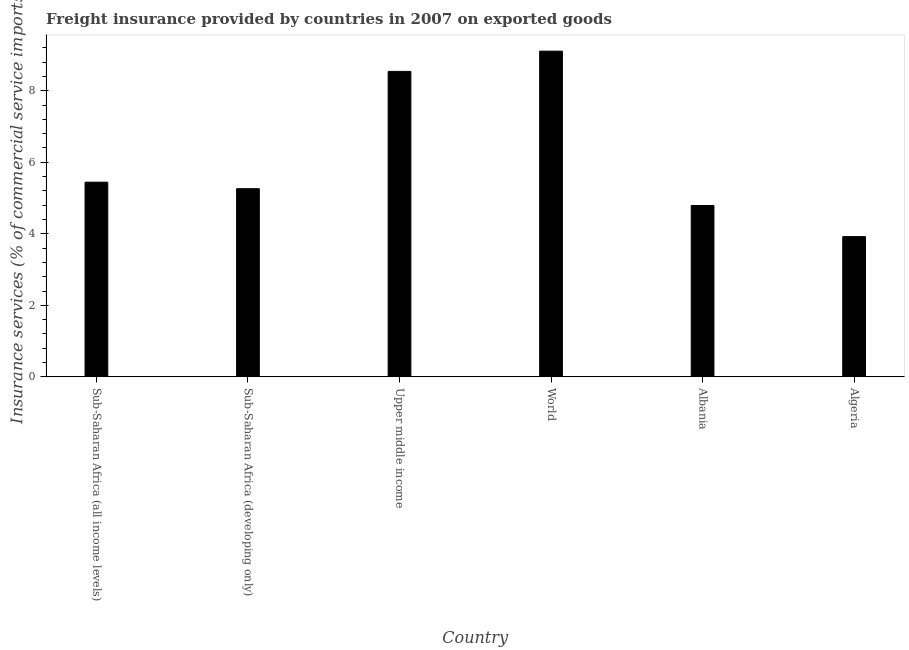Does the graph contain grids?
Your answer should be compact. No. What is the title of the graph?
Offer a very short reply. Freight insurance provided by countries in 2007 on exported goods . What is the label or title of the X-axis?
Provide a succinct answer. Country. What is the label or title of the Y-axis?
Provide a short and direct response. Insurance services (% of commercial service imports). What is the freight insurance in Algeria?
Keep it short and to the point. 3.92. Across all countries, what is the maximum freight insurance?
Ensure brevity in your answer.  9.11. Across all countries, what is the minimum freight insurance?
Offer a very short reply. 3.92. In which country was the freight insurance maximum?
Your response must be concise. World. In which country was the freight insurance minimum?
Make the answer very short. Algeria. What is the sum of the freight insurance?
Provide a succinct answer. 37.06. What is the difference between the freight insurance in Sub-Saharan Africa (all income levels) and Upper middle income?
Ensure brevity in your answer.  -3.1. What is the average freight insurance per country?
Ensure brevity in your answer.  6.18. What is the median freight insurance?
Your response must be concise. 5.35. In how many countries, is the freight insurance greater than 5.2 %?
Offer a very short reply. 4. What is the ratio of the freight insurance in Albania to that in Sub-Saharan Africa (developing only)?
Provide a short and direct response. 0.91. What is the difference between the highest and the second highest freight insurance?
Your answer should be very brief. 0.57. What is the difference between the highest and the lowest freight insurance?
Make the answer very short. 5.18. In how many countries, is the freight insurance greater than the average freight insurance taken over all countries?
Offer a terse response. 2. How many bars are there?
Offer a terse response. 6. Are all the bars in the graph horizontal?
Give a very brief answer. No. How many countries are there in the graph?
Offer a very short reply. 6. What is the difference between two consecutive major ticks on the Y-axis?
Your answer should be compact. 2. Are the values on the major ticks of Y-axis written in scientific E-notation?
Your answer should be very brief. No. What is the Insurance services (% of commercial service imports) in Sub-Saharan Africa (all income levels)?
Make the answer very short. 5.44. What is the Insurance services (% of commercial service imports) in Sub-Saharan Africa (developing only)?
Make the answer very short. 5.26. What is the Insurance services (% of commercial service imports) of Upper middle income?
Offer a terse response. 8.54. What is the Insurance services (% of commercial service imports) of World?
Provide a short and direct response. 9.11. What is the Insurance services (% of commercial service imports) of Albania?
Offer a terse response. 4.79. What is the Insurance services (% of commercial service imports) of Algeria?
Offer a terse response. 3.92. What is the difference between the Insurance services (% of commercial service imports) in Sub-Saharan Africa (all income levels) and Sub-Saharan Africa (developing only)?
Make the answer very short. 0.18. What is the difference between the Insurance services (% of commercial service imports) in Sub-Saharan Africa (all income levels) and Upper middle income?
Your answer should be very brief. -3.1. What is the difference between the Insurance services (% of commercial service imports) in Sub-Saharan Africa (all income levels) and World?
Provide a short and direct response. -3.66. What is the difference between the Insurance services (% of commercial service imports) in Sub-Saharan Africa (all income levels) and Albania?
Provide a succinct answer. 0.65. What is the difference between the Insurance services (% of commercial service imports) in Sub-Saharan Africa (all income levels) and Algeria?
Give a very brief answer. 1.52. What is the difference between the Insurance services (% of commercial service imports) in Sub-Saharan Africa (developing only) and Upper middle income?
Offer a very short reply. -3.28. What is the difference between the Insurance services (% of commercial service imports) in Sub-Saharan Africa (developing only) and World?
Ensure brevity in your answer.  -3.85. What is the difference between the Insurance services (% of commercial service imports) in Sub-Saharan Africa (developing only) and Albania?
Give a very brief answer. 0.47. What is the difference between the Insurance services (% of commercial service imports) in Sub-Saharan Africa (developing only) and Algeria?
Make the answer very short. 1.34. What is the difference between the Insurance services (% of commercial service imports) in Upper middle income and World?
Your answer should be very brief. -0.57. What is the difference between the Insurance services (% of commercial service imports) in Upper middle income and Albania?
Provide a short and direct response. 3.75. What is the difference between the Insurance services (% of commercial service imports) in Upper middle income and Algeria?
Offer a very short reply. 4.62. What is the difference between the Insurance services (% of commercial service imports) in World and Albania?
Your response must be concise. 4.31. What is the difference between the Insurance services (% of commercial service imports) in World and Algeria?
Make the answer very short. 5.18. What is the difference between the Insurance services (% of commercial service imports) in Albania and Algeria?
Offer a very short reply. 0.87. What is the ratio of the Insurance services (% of commercial service imports) in Sub-Saharan Africa (all income levels) to that in Sub-Saharan Africa (developing only)?
Keep it short and to the point. 1.03. What is the ratio of the Insurance services (% of commercial service imports) in Sub-Saharan Africa (all income levels) to that in Upper middle income?
Provide a succinct answer. 0.64. What is the ratio of the Insurance services (% of commercial service imports) in Sub-Saharan Africa (all income levels) to that in World?
Provide a short and direct response. 0.6. What is the ratio of the Insurance services (% of commercial service imports) in Sub-Saharan Africa (all income levels) to that in Albania?
Your answer should be very brief. 1.14. What is the ratio of the Insurance services (% of commercial service imports) in Sub-Saharan Africa (all income levels) to that in Algeria?
Ensure brevity in your answer.  1.39. What is the ratio of the Insurance services (% of commercial service imports) in Sub-Saharan Africa (developing only) to that in Upper middle income?
Your response must be concise. 0.62. What is the ratio of the Insurance services (% of commercial service imports) in Sub-Saharan Africa (developing only) to that in World?
Offer a terse response. 0.58. What is the ratio of the Insurance services (% of commercial service imports) in Sub-Saharan Africa (developing only) to that in Albania?
Provide a succinct answer. 1.1. What is the ratio of the Insurance services (% of commercial service imports) in Sub-Saharan Africa (developing only) to that in Algeria?
Make the answer very short. 1.34. What is the ratio of the Insurance services (% of commercial service imports) in Upper middle income to that in World?
Give a very brief answer. 0.94. What is the ratio of the Insurance services (% of commercial service imports) in Upper middle income to that in Albania?
Your response must be concise. 1.78. What is the ratio of the Insurance services (% of commercial service imports) in Upper middle income to that in Algeria?
Make the answer very short. 2.18. What is the ratio of the Insurance services (% of commercial service imports) in World to that in Albania?
Provide a short and direct response. 1.9. What is the ratio of the Insurance services (% of commercial service imports) in World to that in Algeria?
Keep it short and to the point. 2.32. What is the ratio of the Insurance services (% of commercial service imports) in Albania to that in Algeria?
Make the answer very short. 1.22. 